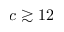<formula> <loc_0><loc_0><loc_500><loc_500>c \gtrsim 1 2</formula> 